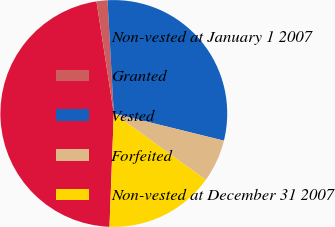<chart> <loc_0><loc_0><loc_500><loc_500><pie_chart><fcel>Non-vested at January 1 2007<fcel>Granted<fcel>Vested<fcel>Forfeited<fcel>Non-vested at December 31 2007<nl><fcel>46.95%<fcel>1.56%<fcel>29.73%<fcel>6.1%<fcel>15.65%<nl></chart> 